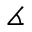<formula> <loc_0><loc_0><loc_500><loc_500>\measuredangle</formula> 